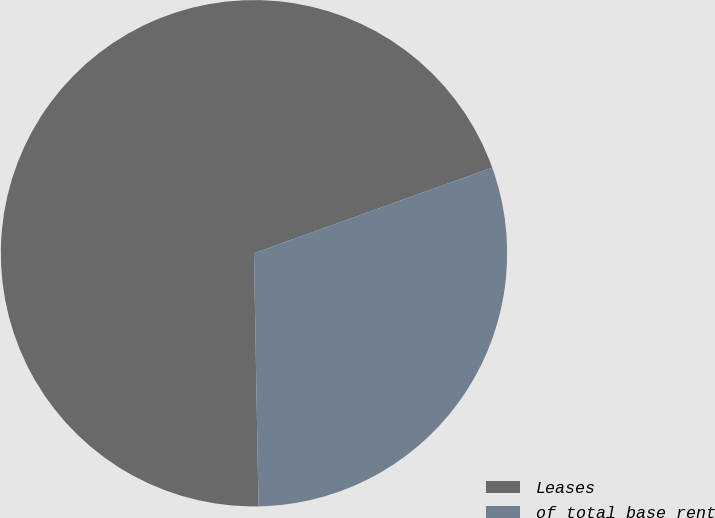<chart> <loc_0><loc_0><loc_500><loc_500><pie_chart><fcel>Leases<fcel>of total base rent<nl><fcel>69.79%<fcel>30.21%<nl></chart> 